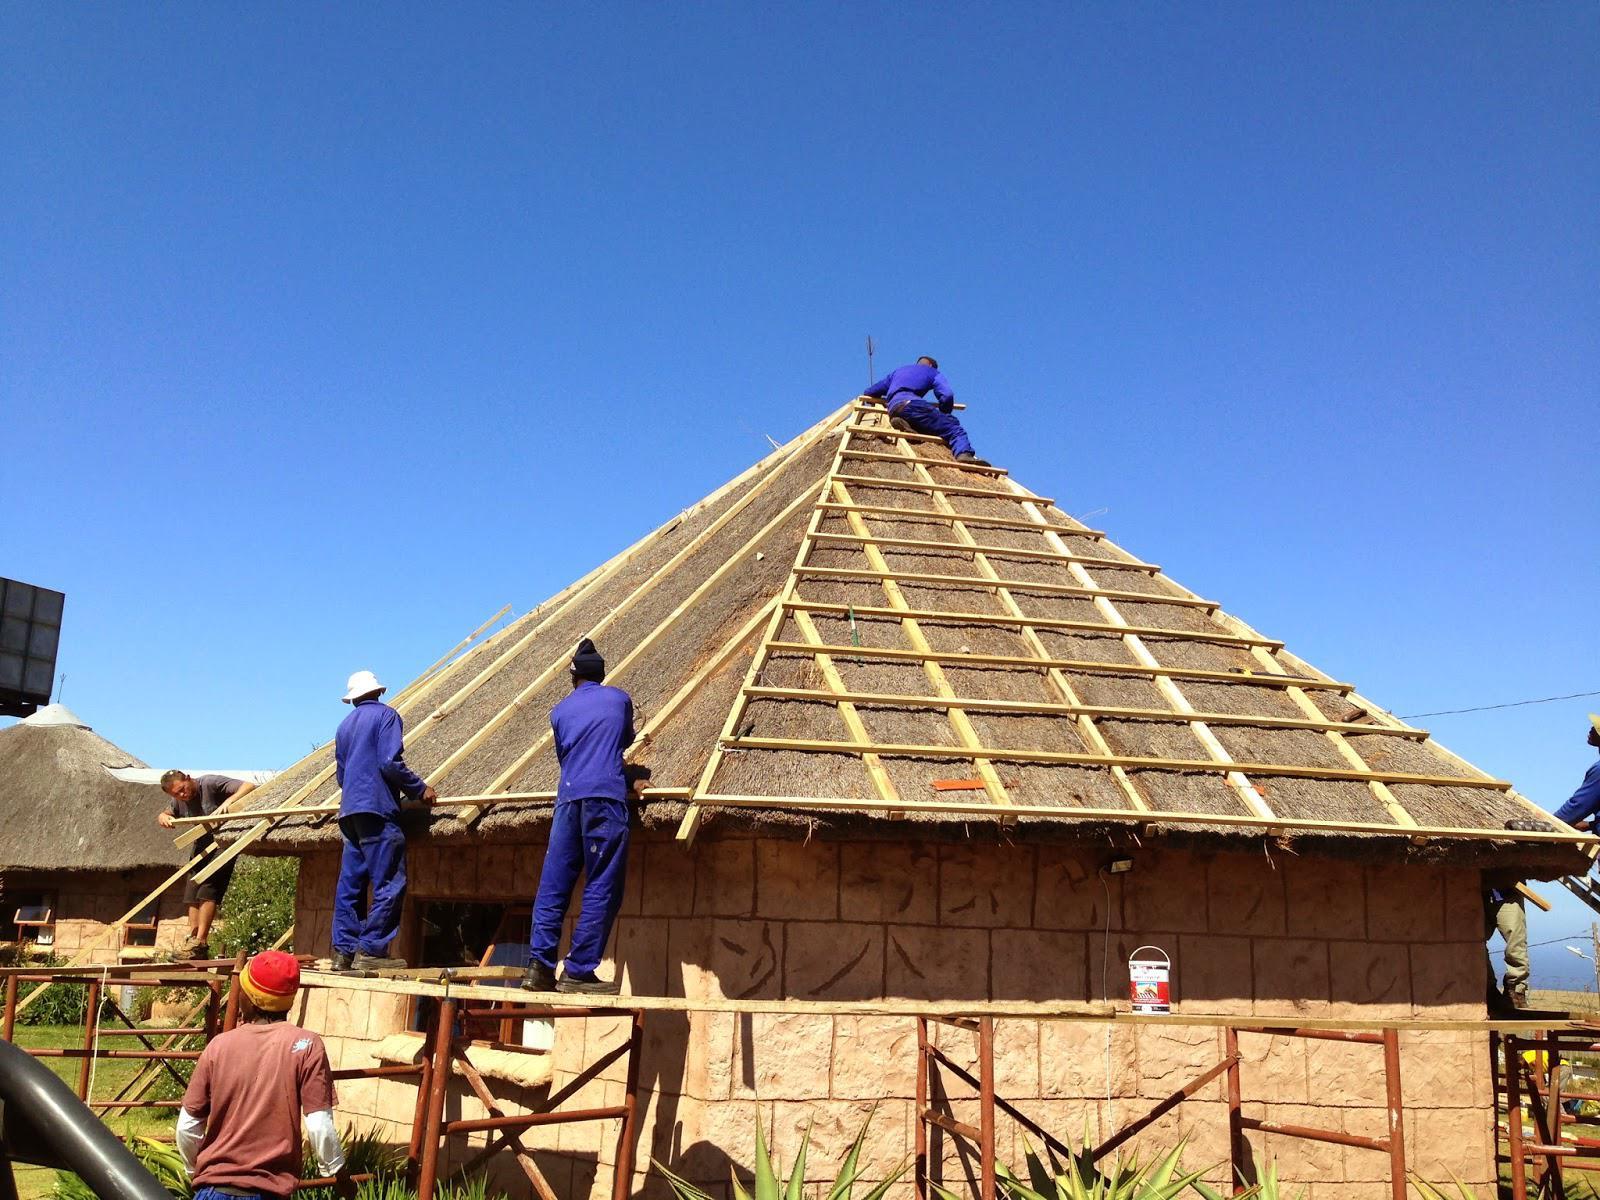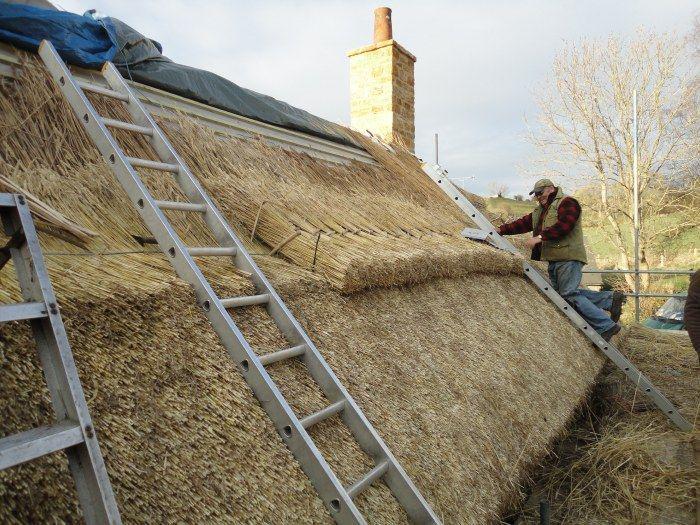The first image is the image on the left, the second image is the image on the right. Considering the images on both sides, is "At least one ladder is touching the thatch." valid? Answer yes or no. Yes. 